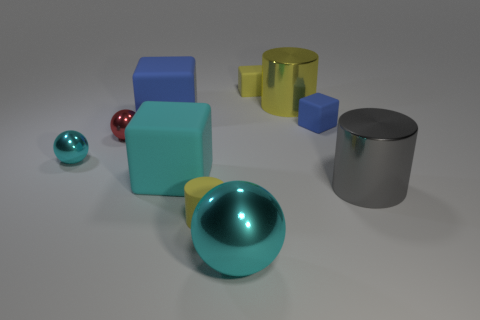Subtract all cyan cubes. How many yellow cylinders are left? 2 Subtract 1 balls. How many balls are left? 2 Subtract all big cyan matte cubes. How many cubes are left? 3 Subtract all cyan blocks. How many blocks are left? 3 Subtract all red blocks. Subtract all red cylinders. How many blocks are left? 4 Subtract 0 brown spheres. How many objects are left? 10 Subtract all cubes. How many objects are left? 6 Subtract all tiny cyan spheres. Subtract all yellow cylinders. How many objects are left? 7 Add 5 large gray metallic objects. How many large gray metallic objects are left? 6 Add 7 big blue rubber objects. How many big blue rubber objects exist? 8 